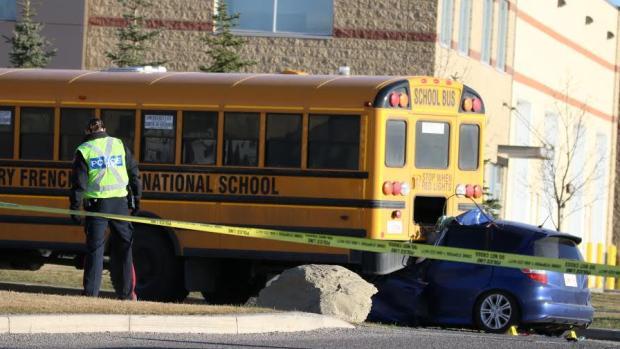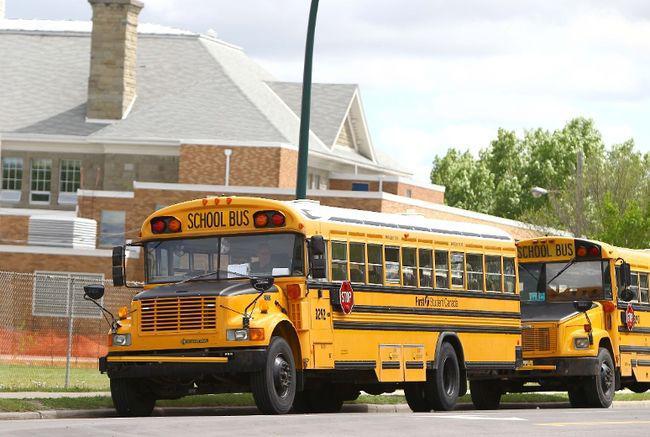The first image is the image on the left, the second image is the image on the right. Examine the images to the left and right. Is the description "There are two buses going in opposite directions." accurate? Answer yes or no. No. The first image is the image on the left, the second image is the image on the right. Assess this claim about the two images: "One of the images shows a school bus that has had an accident.". Correct or not? Answer yes or no. Yes. 